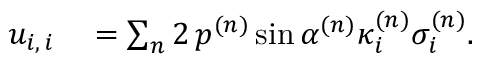<formula> <loc_0><loc_0><loc_500><loc_500>\begin{array} { r l } { u _ { i , \, i } } & = \sum _ { n } 2 \, p ^ { ( n ) } \sin \alpha ^ { ( n ) } \kappa _ { i } ^ { ( n ) } \sigma _ { i } ^ { ( n ) } . } \end{array}</formula> 